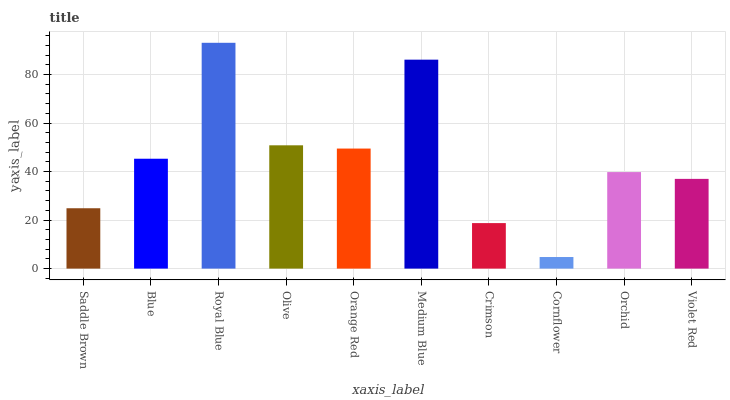Is Cornflower the minimum?
Answer yes or no. Yes. Is Royal Blue the maximum?
Answer yes or no. Yes. Is Blue the minimum?
Answer yes or no. No. Is Blue the maximum?
Answer yes or no. No. Is Blue greater than Saddle Brown?
Answer yes or no. Yes. Is Saddle Brown less than Blue?
Answer yes or no. Yes. Is Saddle Brown greater than Blue?
Answer yes or no. No. Is Blue less than Saddle Brown?
Answer yes or no. No. Is Blue the high median?
Answer yes or no. Yes. Is Orchid the low median?
Answer yes or no. Yes. Is Violet Red the high median?
Answer yes or no. No. Is Cornflower the low median?
Answer yes or no. No. 